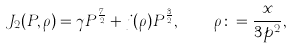Convert formula to latex. <formula><loc_0><loc_0><loc_500><loc_500>J _ { 2 } ( P , \rho ) = \gamma P ^ { \frac { 7 } { 2 } } + j ( \rho ) P ^ { \frac { 3 } { 2 } } , \quad \rho \colon = \frac { x } { 3 p ^ { 2 } } ,</formula> 